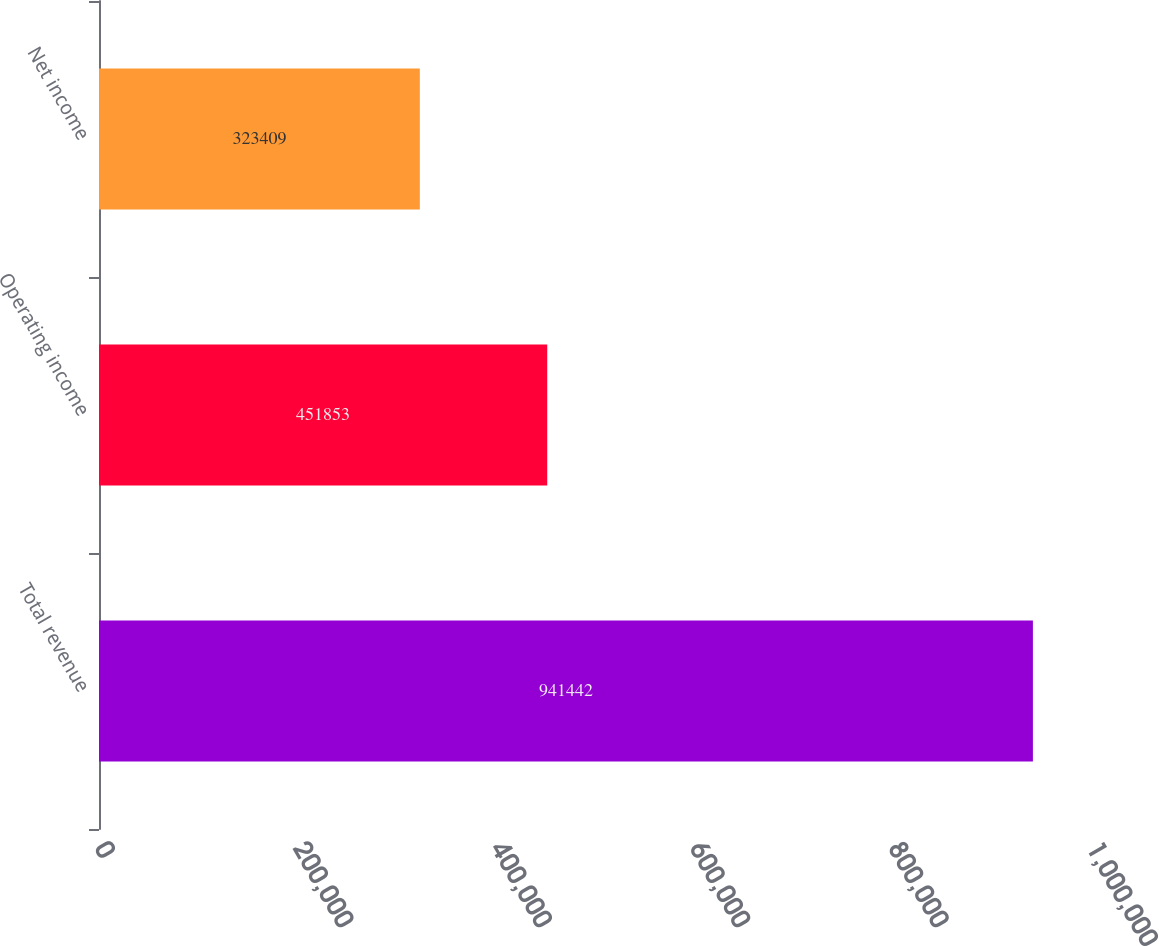Convert chart to OTSL. <chart><loc_0><loc_0><loc_500><loc_500><bar_chart><fcel>Total revenue<fcel>Operating income<fcel>Net income<nl><fcel>941442<fcel>451853<fcel>323409<nl></chart> 